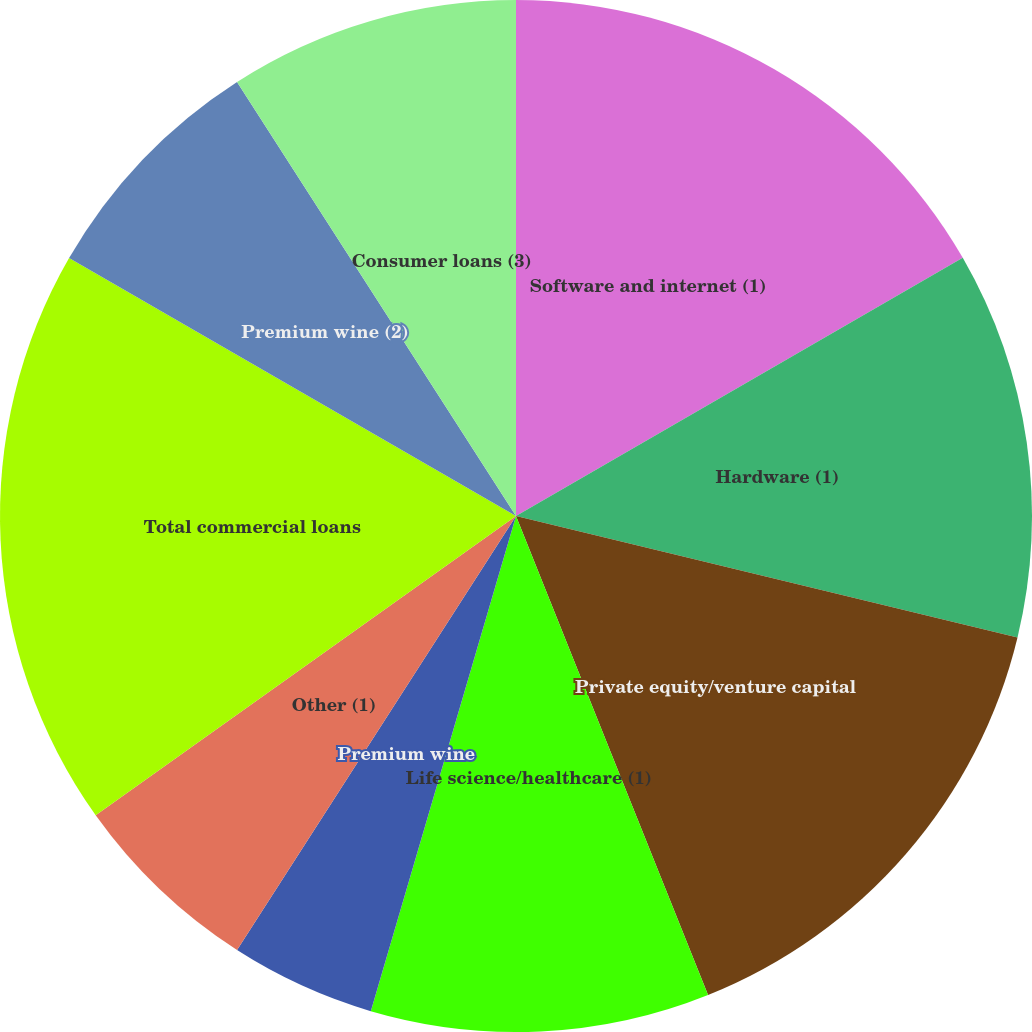<chart> <loc_0><loc_0><loc_500><loc_500><pie_chart><fcel>(Dollars in thousands)<fcel>Software and internet (1)<fcel>Hardware (1)<fcel>Private equity/venture capital<fcel>Life science/healthcare (1)<fcel>Premium wine<fcel>Other (1)<fcel>Total commercial loans<fcel>Premium wine (2)<fcel>Consumer loans (3)<nl><fcel>0.0%<fcel>16.66%<fcel>12.12%<fcel>15.15%<fcel>10.61%<fcel>4.55%<fcel>6.06%<fcel>18.18%<fcel>7.58%<fcel>9.09%<nl></chart> 